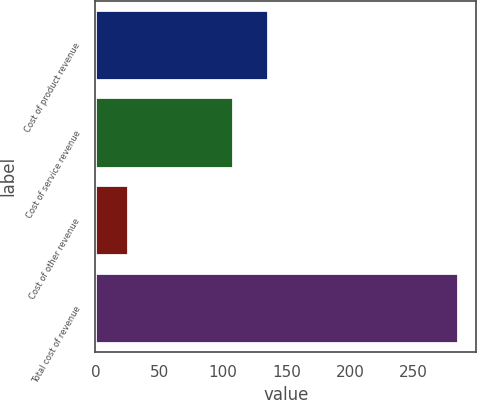Convert chart. <chart><loc_0><loc_0><loc_500><loc_500><bar_chart><fcel>Cost of product revenue<fcel>Cost of service revenue<fcel>Cost of other revenue<fcel>Total cost of revenue<nl><fcel>135.6<fcel>108.3<fcel>26<fcel>284.8<nl></chart> 